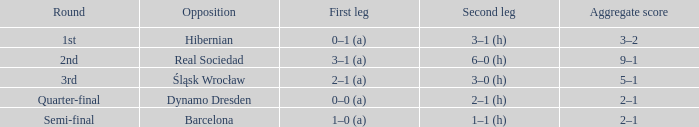What was the first leg score against Real Sociedad? 3–1 (a). 